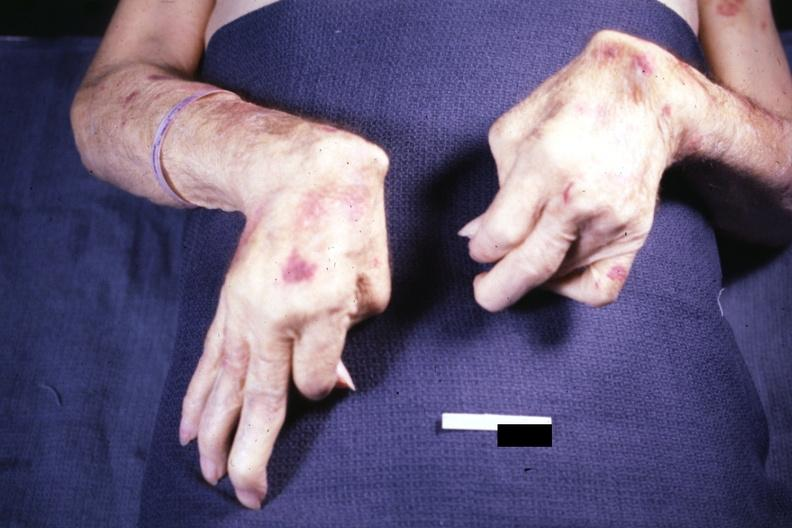does this image show good example exposure not the best but ok rheumatoid arthritis?
Answer the question using a single word or phrase. Yes 